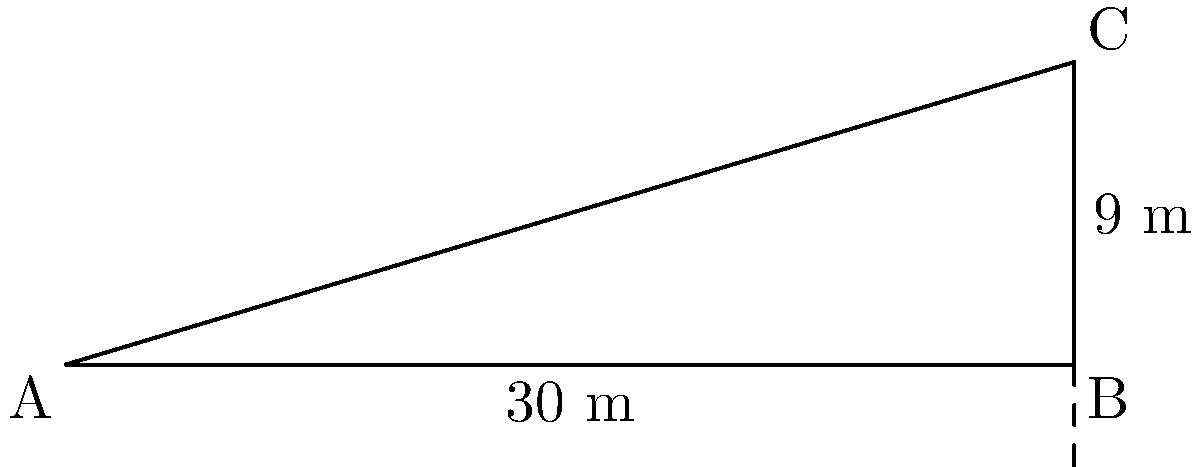While exploring Samarkand, you encounter a steep street. The horizontal distance from the bottom to the top of the street is 30 meters, and the vertical height difference is 9 meters. What is the angle of inclination of this street? To find the angle of inclination, we need to use trigonometry. Let's approach this step-by-step:

1. We have a right-angled triangle where:
   - The base (horizontal distance) is 30 meters
   - The height (vertical distance) is 9 meters
   - The angle of inclination is what we're looking for

2. In a right-angled triangle, the tangent of an angle is the ratio of the opposite side to the adjacent side.

3. In this case:
   - The opposite side is the height (9 m)
   - The adjacent side is the base (30 m)

4. We can express this as:

   $$\tan(\theta) = \frac{\text{opposite}}{\text{adjacent}} = \frac{9}{30} = 0.3$$

5. To find the angle $\theta$, we need to use the inverse tangent (arctan or $\tan^{-1}$):

   $$\theta = \tan^{-1}(0.3)$$

6. Using a calculator or trigonometric tables:

   $$\theta \approx 16.70^\circ$$

Therefore, the angle of inclination of the street is approximately 16.70°.
Answer: $16.70^\circ$ 